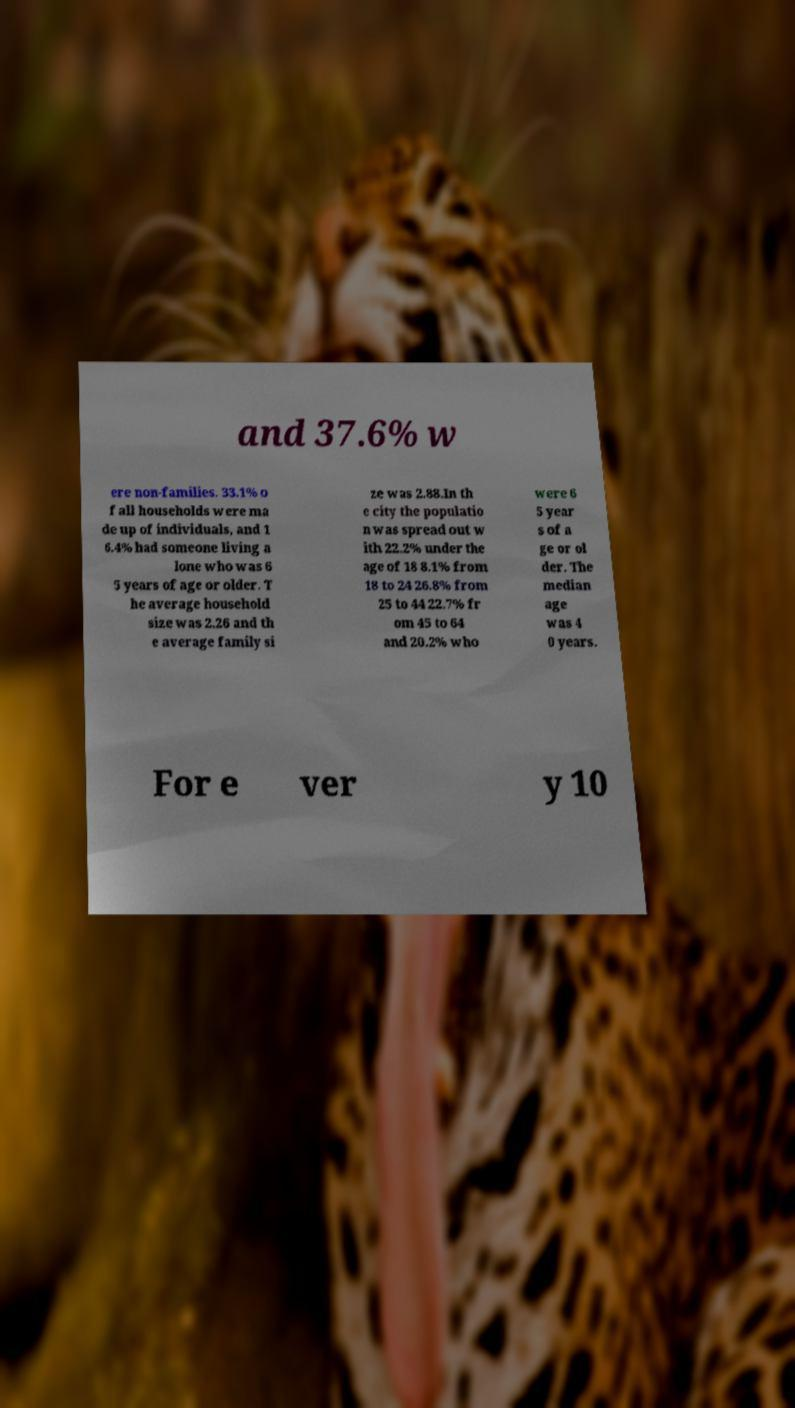Can you read and provide the text displayed in the image?This photo seems to have some interesting text. Can you extract and type it out for me? and 37.6% w ere non-families. 33.1% o f all households were ma de up of individuals, and 1 6.4% had someone living a lone who was 6 5 years of age or older. T he average household size was 2.26 and th e average family si ze was 2.88.In th e city the populatio n was spread out w ith 22.2% under the age of 18 8.1% from 18 to 24 26.8% from 25 to 44 22.7% fr om 45 to 64 and 20.2% who were 6 5 year s of a ge or ol der. The median age was 4 0 years. For e ver y 10 